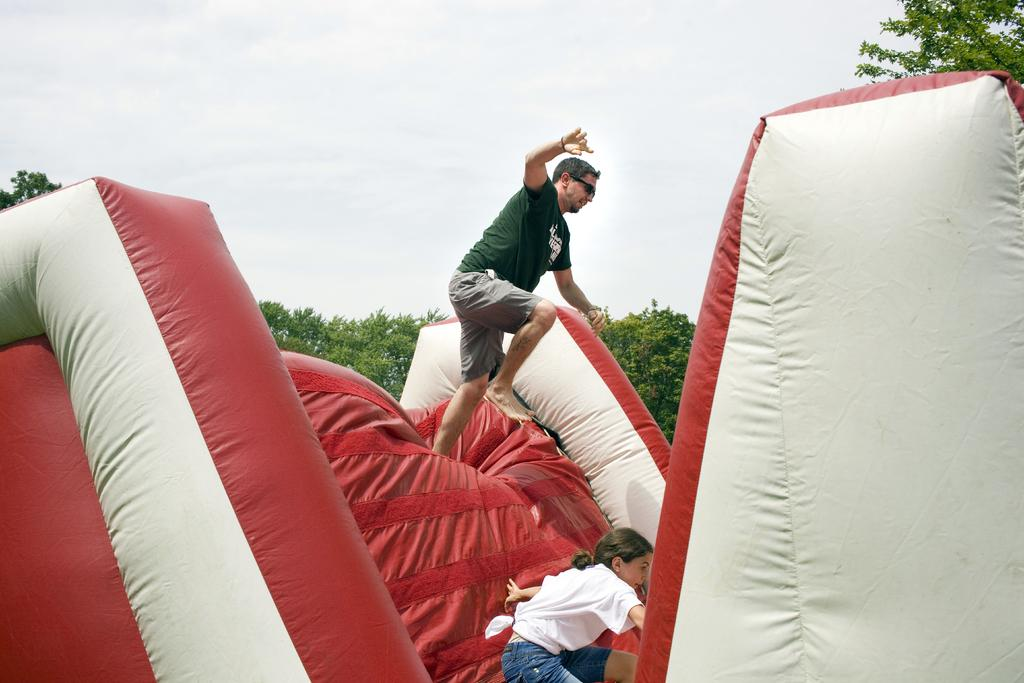What are the two persons doing in the image? The two persons are on a balloon castle in the image. What can be seen in the middle of the image besides the balloon castle? Trees are present in the middle of the image. What is visible at the top of the image? The sky is visible at the top of the image. What type of lamp is hanging from the balloon castle in the image? There is no lamp present on the balloon castle in the image. Can you describe the health of the frog sitting on the balloon castle? There is no frog present on the balloon castle in the image. 